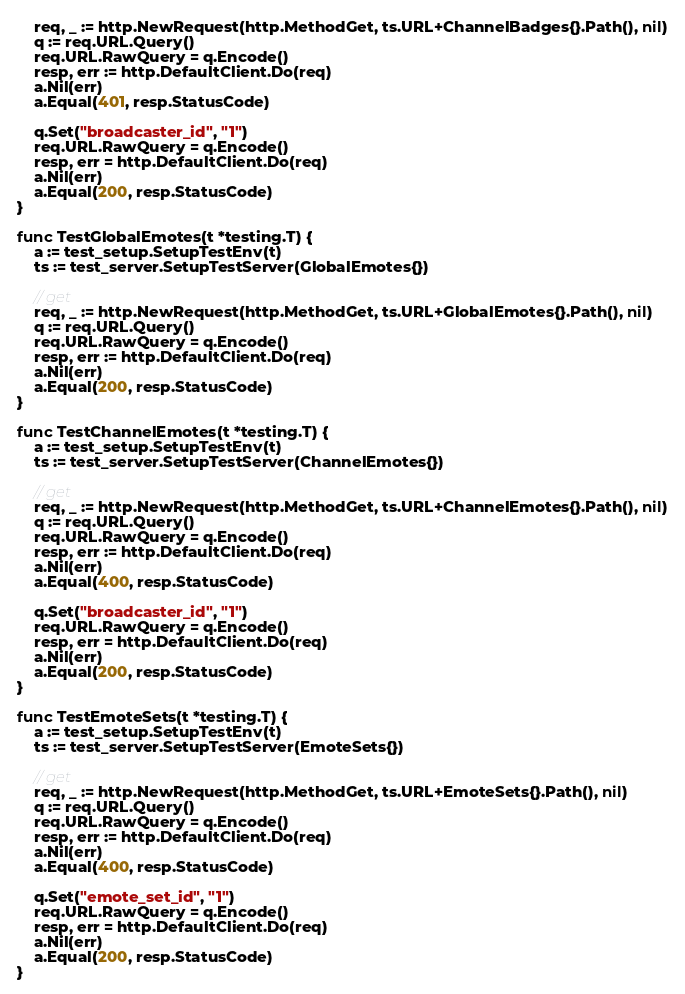<code> <loc_0><loc_0><loc_500><loc_500><_Go_>	req, _ := http.NewRequest(http.MethodGet, ts.URL+ChannelBadges{}.Path(), nil)
	q := req.URL.Query()
	req.URL.RawQuery = q.Encode()
	resp, err := http.DefaultClient.Do(req)
	a.Nil(err)
	a.Equal(401, resp.StatusCode)

	q.Set("broadcaster_id", "1")
	req.URL.RawQuery = q.Encode()
	resp, err = http.DefaultClient.Do(req)
	a.Nil(err)
	a.Equal(200, resp.StatusCode)
}

func TestGlobalEmotes(t *testing.T) {
	a := test_setup.SetupTestEnv(t)
	ts := test_server.SetupTestServer(GlobalEmotes{})

	// get
	req, _ := http.NewRequest(http.MethodGet, ts.URL+GlobalEmotes{}.Path(), nil)
	q := req.URL.Query()
	req.URL.RawQuery = q.Encode()
	resp, err := http.DefaultClient.Do(req)
	a.Nil(err)
	a.Equal(200, resp.StatusCode)
}

func TestChannelEmotes(t *testing.T) {
	a := test_setup.SetupTestEnv(t)
	ts := test_server.SetupTestServer(ChannelEmotes{})

	// get
	req, _ := http.NewRequest(http.MethodGet, ts.URL+ChannelEmotes{}.Path(), nil)
	q := req.URL.Query()
	req.URL.RawQuery = q.Encode()
	resp, err := http.DefaultClient.Do(req)
	a.Nil(err)
	a.Equal(400, resp.StatusCode)

	q.Set("broadcaster_id", "1")
	req.URL.RawQuery = q.Encode()
	resp, err = http.DefaultClient.Do(req)
	a.Nil(err)
	a.Equal(200, resp.StatusCode)
}

func TestEmoteSets(t *testing.T) {
	a := test_setup.SetupTestEnv(t)
	ts := test_server.SetupTestServer(EmoteSets{})

	// get
	req, _ := http.NewRequest(http.MethodGet, ts.URL+EmoteSets{}.Path(), nil)
	q := req.URL.Query()
	req.URL.RawQuery = q.Encode()
	resp, err := http.DefaultClient.Do(req)
	a.Nil(err)
	a.Equal(400, resp.StatusCode)

	q.Set("emote_set_id", "1")
	req.URL.RawQuery = q.Encode()
	resp, err = http.DefaultClient.Do(req)
	a.Nil(err)
	a.Equal(200, resp.StatusCode)
}
</code> 